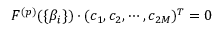Convert formula to latex. <formula><loc_0><loc_0><loc_500><loc_500>F ^ { ( p ) } ( \{ \beta _ { i } \} ) \cdot ( c _ { 1 } , c _ { 2 } , \cdots , c _ { 2 M } ) ^ { T } = 0</formula> 